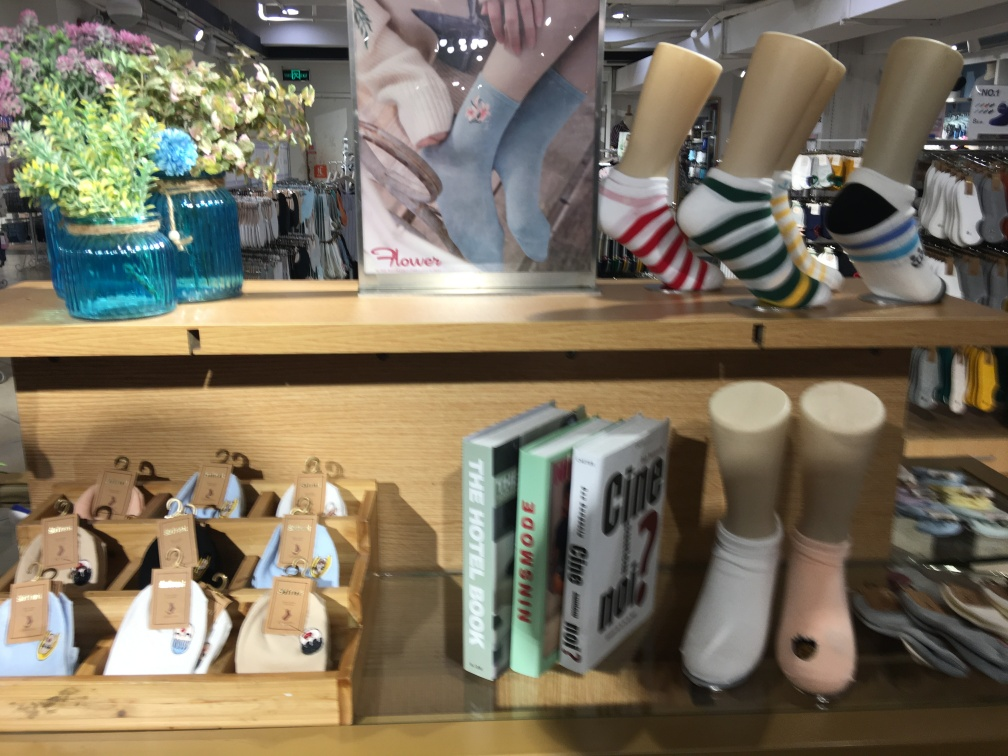Are there any quality issues with this image? Yes, the image appears to be slightly blurry, particularly around the text on the books and the edges of the objects. It could be due to camera movement during exposure or a focus issue. Additionally, there is a visible reflection on the shiny surface in the background that might distract from the main subjects. 